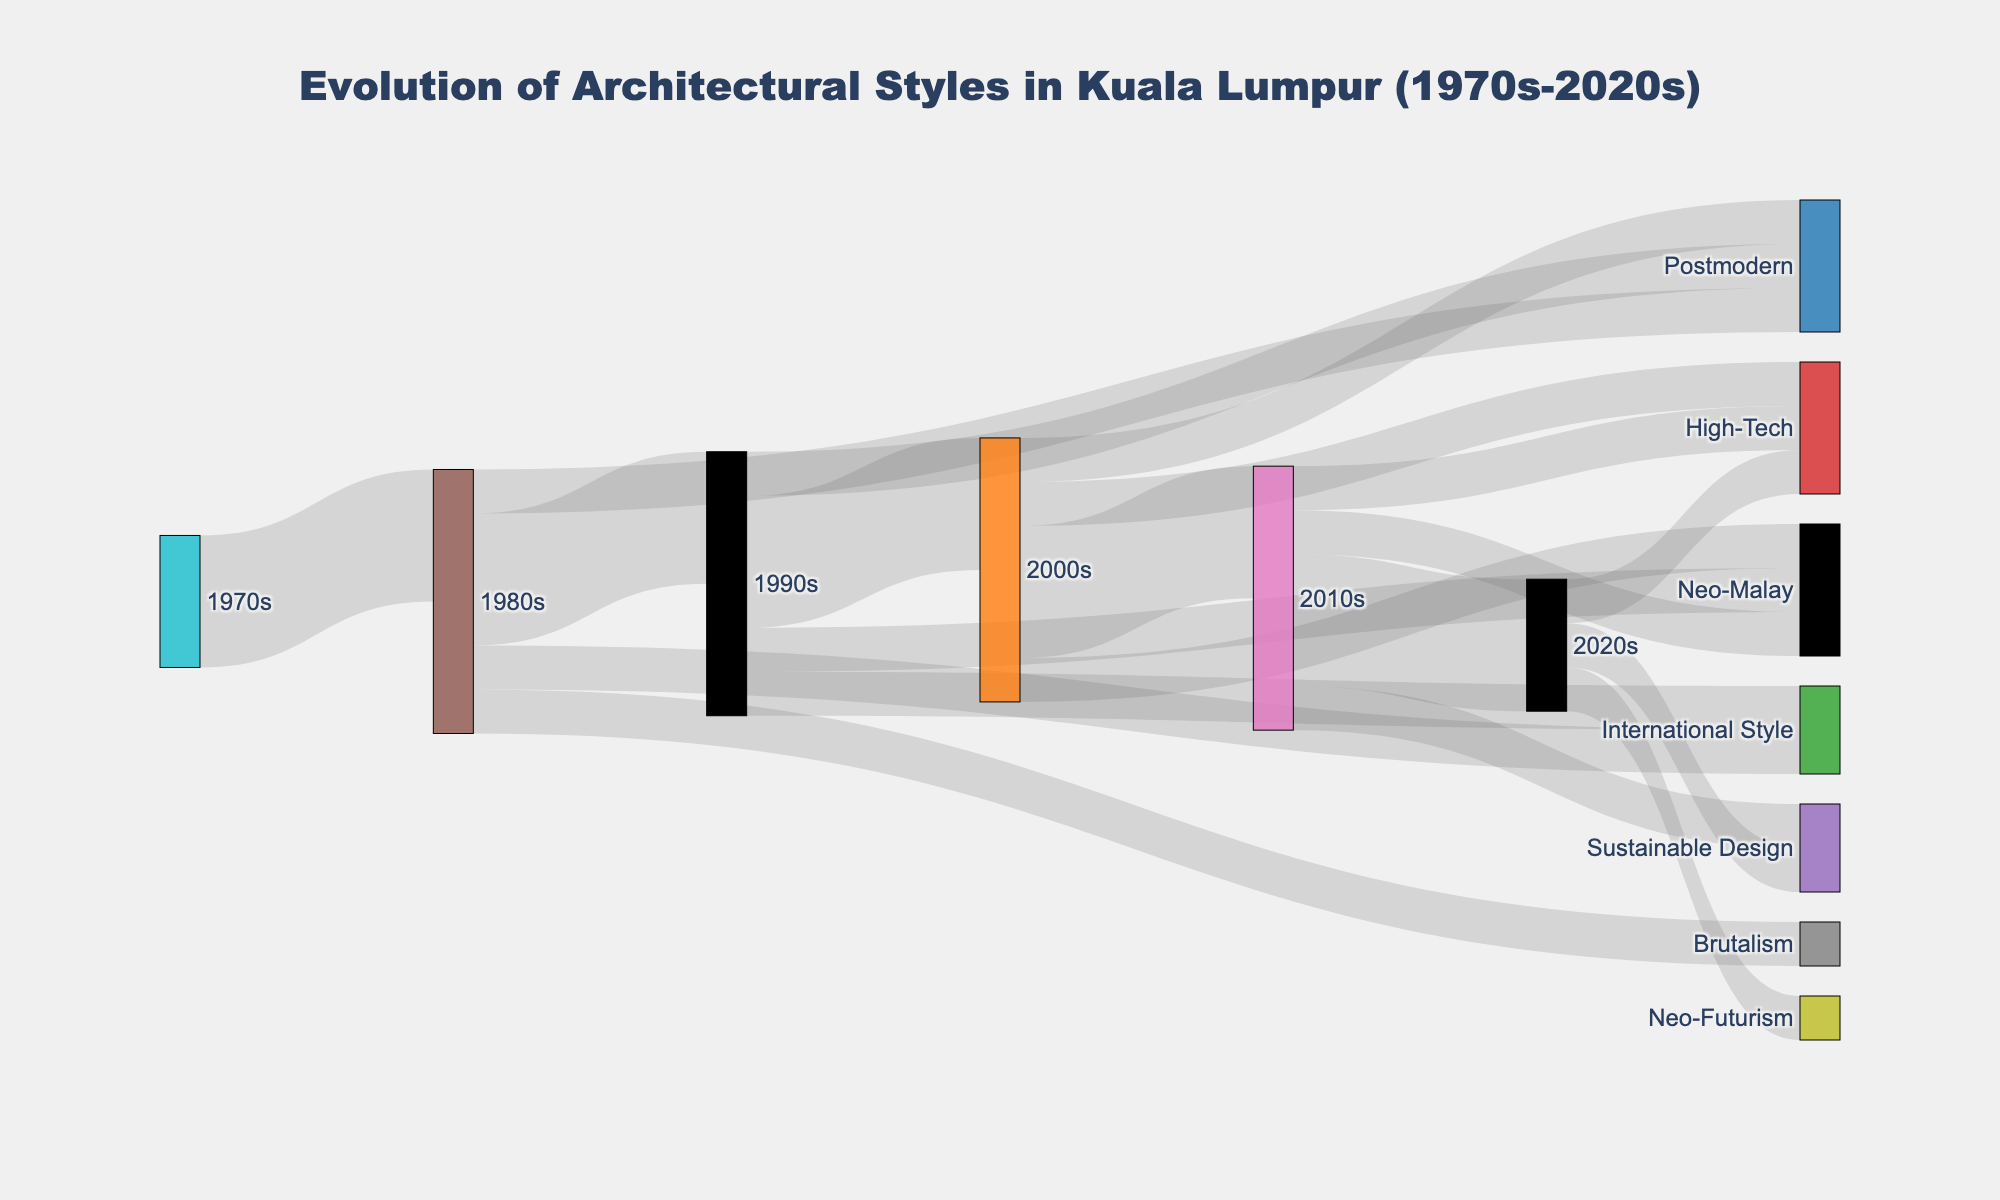Which architectural style appeared in the 2010s for the first time? To identify the style that debuted in the 2010s, observe the connections stemming from the 2010s node to architectural styles. Neo-Futurism is first seen in the 2010s.
Answer: Neo-Futurism How many architectural styles are shown in the diagram during the 1990s? Look at the connections from the 1990s node to count distinct styles. The architectural styles include Postmodern, Neo-Malay, and High-Tech, totaling 3.
Answer: 3 Which decades did the Neo-Malay style span? Follow the connections to and from Neo-Malay. It extends across the 1990s, 2000s, and 2010s.
Answer: 1990s, 2000s, 2010s What is the trend of High-Tech architectural style from 1990s to 2020s? Trace the connections to and from High-Tech across the decades. It appears in the 2000s, 2010s, and 2020s, indicating continuity across these decades.
Answer: Continuously present from 2000s to 2020s Is Brutalism still present in Kuala Lumpur's skyline in the 2020s? Check for connections from Brutalism to any subsequent decades or styles. Brutalism is only seen in the 1980s and does not connect beyond this.
Answer: No Which architectural style from the 1980s continued into the 1990s and still appeared in a later decade? Look for styles with connections from the 1980s onward. International Style connects from the 1980s to the 1990s but does not continue further. Postmodern continues from the 1980s, then appears in the 1990s and 2000s.
Answer: Postmodern How many architectural styles are represented in the diagram? Count all unique architectural style nodes. There are 9 styles: International Style, Brutalism, Postmodern, Neo-Malay, High-Tech, Sustainable Design, Neo-Futurism.
Answer: 9 Which decade saw the introduction of the most new architectural styles? Compare the number of new styles introduced in each decade. The 1970s saw 3 (International Style, Brutalism, Postmodern), 1980s saw 3 (Neo-Malay, Postmodern, International Style), 1990s saw 3 (Neo-Malay, High-Tech, Postmodern), 2000s saw 3 (Neo-Malay, High-Tech, Sustainable Design), and 2010s saw 3 (High-Tech, Sustainable Design, Neo-Futurism). All decades introduced 3 new styles.
Answer: Equal across decades 